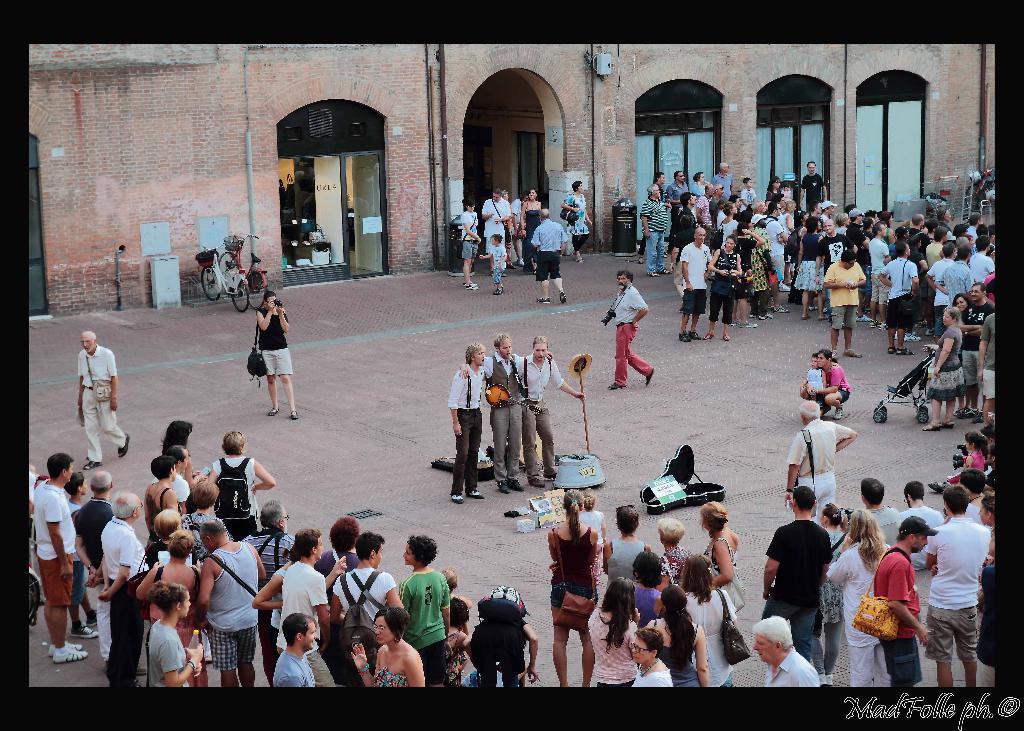Could you give a brief overview of what you see in this image? In this image I can see group of people are standing among them some are holding some objects. In the background I can see a building, a bicycle and some other objects on the ground. 